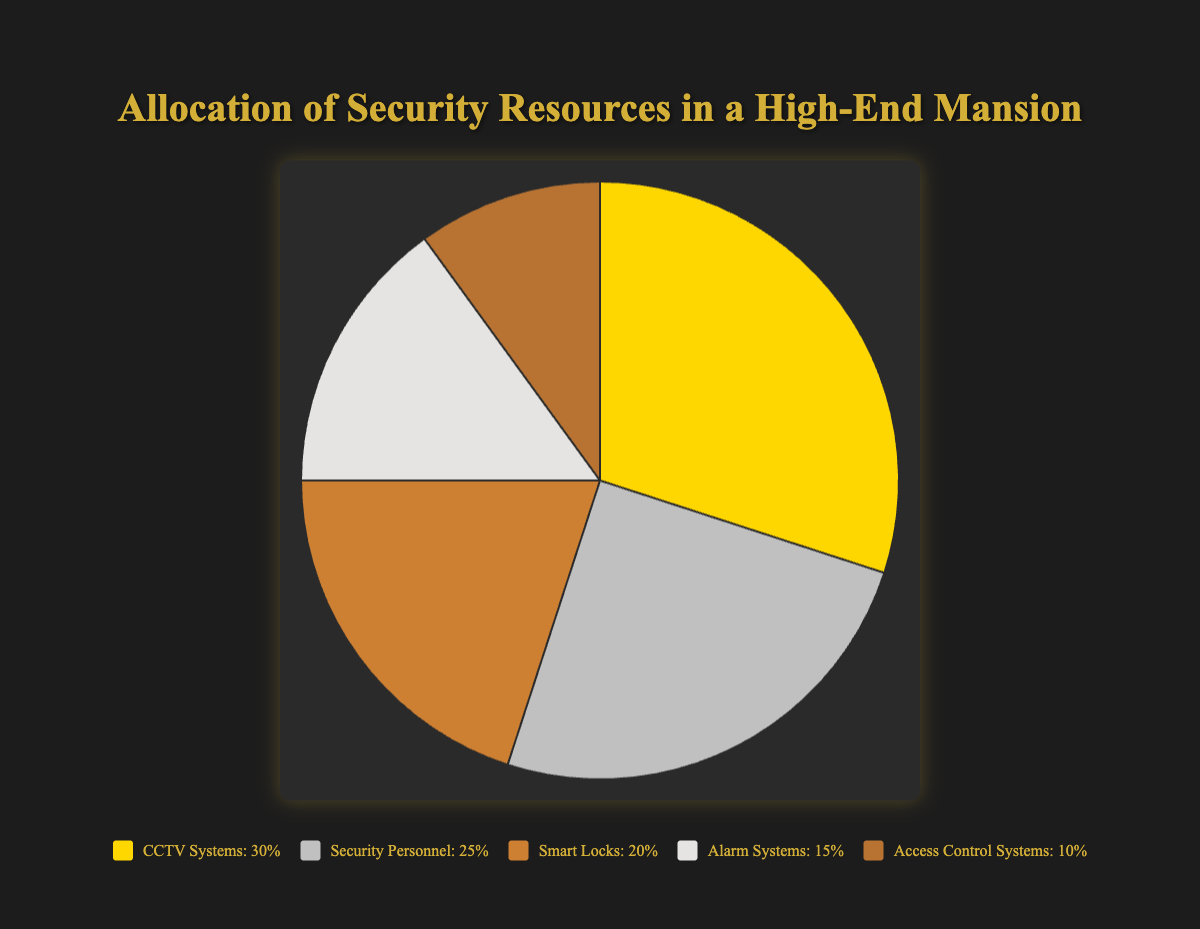How much more of the security resources are allocated to CCTV Systems compared to Alarm Systems? To find how much more is allocated to CCTV Systems compared to Alarm Systems, subtract the percentage allocated to Alarm Systems (15%) from the percentage allocated to CCTV Systems (30%). 30% - 15% = 15%. So, CCTV Systems have 15% more resources allocated compared to Alarm Systems.
Answer: 15% What is the combined percentage of resources allocated to Smart Locks and Access Control Systems? To find the combined percentage of resources allocated to Smart Locks and Access Control Systems, add their respective percentages. Smart Locks are allocated 20% and Access Control Systems 10%, so 20% + 10% = 30%.
Answer: 30% Which security resource category is allocated the least percentage? To determine the category with the least allocation, compare all the percentage values. Access Control Systems have the lowest allocation at 10%.
Answer: Access Control Systems What is the ratio of resources allocated to Security Personnel versus Alarm Systems? To find the ratio of resources, compare the percentages allocated to Security Personnel and Alarm Systems. Security Personnel are allocated 25% and Alarm Systems 15%. The ratio is 25:15, which simplifies to 5:3.
Answer: 5:3 Which category has a higher allocation: Smart Locks or Security Personnel? Compare the allocation percentages of Smart Locks and Security Personnel. Smart Locks are allocated 20%, while Security Personnel are allocated 25%. Security Personnel have a higher allocation.
Answer: Security Personnel If you were to increase the allocation of Alarm Systems by 5%, what would be the new percentage allocation for Alarm Systems? To find the new allocation, add 5% to the current allocation of Alarm Systems, which is 15%. Thus, 15% + 5% = 20%.
Answer: 20% How many more percentage points are allocated to CCTV Systems than Smart Locks? To determine how many more percentage points are allocated to CCTV Systems compared to Smart Locks, subtract the percentage allocated to Smart Locks (20%) from the percentage allocated to CCTV Systems (30%). 30% - 20% = 10%.
Answer: 10% What fraction of the resources is allocated to Alarm Systems? To find the fraction of resources allocated to Alarm Systems, consider the percentage allocation. Alarm Systems are allocated 15%, which as a fraction is 15/100 or simplified to 3/20.
Answer: 3/20 How does the combined percentage allocation of CCTV Systems and Smart Locks compare to the allocation of Security Personnel? To find the combined percentage allocation of CCTV Systems and Smart Locks, add their respective percentages: 30% (CCTV Systems) + 20% (Smart Locks) = 50%. Compare this to Security Personnel's allocation of 25%. 50% is greater than 25%.
Answer: 50% is greater 